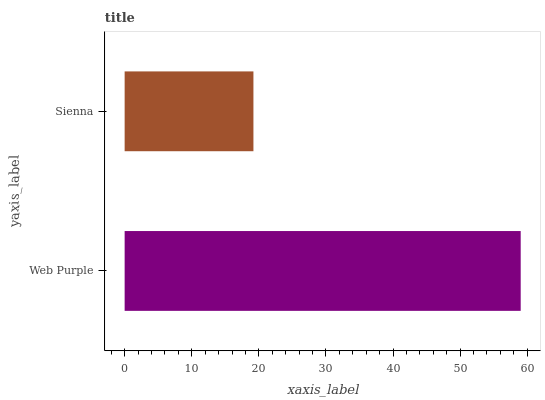Is Sienna the minimum?
Answer yes or no. Yes. Is Web Purple the maximum?
Answer yes or no. Yes. Is Sienna the maximum?
Answer yes or no. No. Is Web Purple greater than Sienna?
Answer yes or no. Yes. Is Sienna less than Web Purple?
Answer yes or no. Yes. Is Sienna greater than Web Purple?
Answer yes or no. No. Is Web Purple less than Sienna?
Answer yes or no. No. Is Web Purple the high median?
Answer yes or no. Yes. Is Sienna the low median?
Answer yes or no. Yes. Is Sienna the high median?
Answer yes or no. No. Is Web Purple the low median?
Answer yes or no. No. 